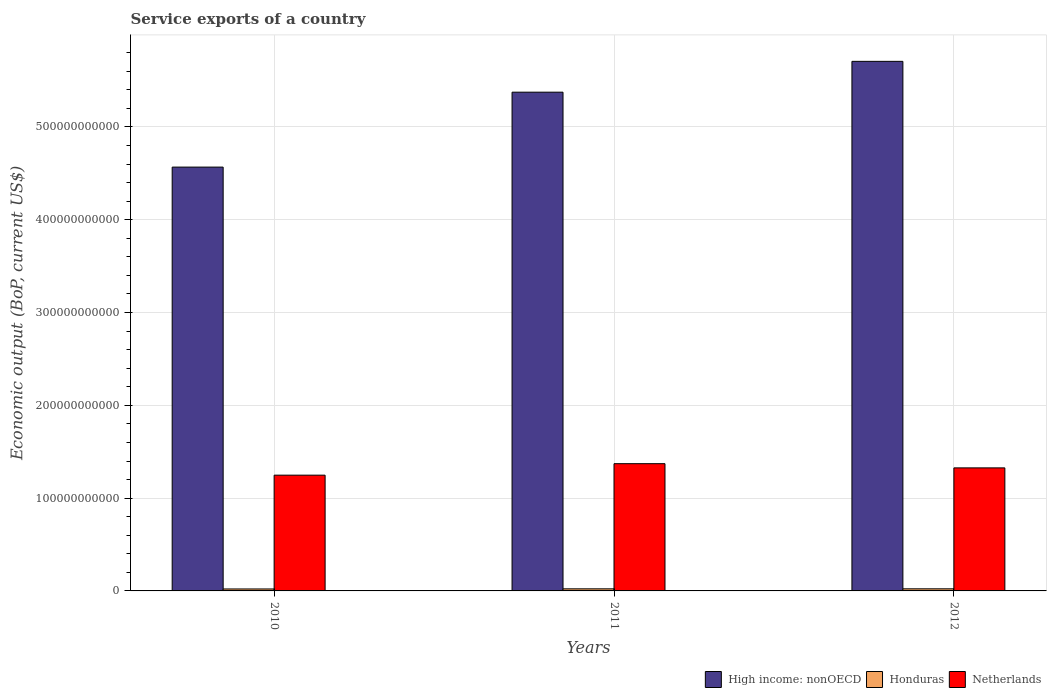Are the number of bars per tick equal to the number of legend labels?
Your answer should be compact. Yes. Are the number of bars on each tick of the X-axis equal?
Ensure brevity in your answer.  Yes. What is the label of the 3rd group of bars from the left?
Your answer should be compact. 2012. In how many cases, is the number of bars for a given year not equal to the number of legend labels?
Offer a very short reply. 0. What is the service exports in High income: nonOECD in 2010?
Give a very brief answer. 4.57e+11. Across all years, what is the maximum service exports in Netherlands?
Your answer should be compact. 1.37e+11. Across all years, what is the minimum service exports in Netherlands?
Your response must be concise. 1.25e+11. What is the total service exports in Honduras in the graph?
Offer a very short reply. 6.62e+09. What is the difference between the service exports in Honduras in 2010 and that in 2011?
Ensure brevity in your answer.  -1.46e+08. What is the difference between the service exports in High income: nonOECD in 2011 and the service exports in Netherlands in 2012?
Your response must be concise. 4.05e+11. What is the average service exports in Netherlands per year?
Give a very brief answer. 1.31e+11. In the year 2011, what is the difference between the service exports in Netherlands and service exports in High income: nonOECD?
Give a very brief answer. -4.00e+11. What is the ratio of the service exports in High income: nonOECD in 2011 to that in 2012?
Offer a terse response. 0.94. What is the difference between the highest and the second highest service exports in Honduras?
Offer a very short reply. 3.58e+06. What is the difference between the highest and the lowest service exports in Honduras?
Provide a short and direct response. 1.50e+08. In how many years, is the service exports in Netherlands greater than the average service exports in Netherlands taken over all years?
Your answer should be compact. 2. Is the sum of the service exports in High income: nonOECD in 2010 and 2011 greater than the maximum service exports in Honduras across all years?
Ensure brevity in your answer.  Yes. What does the 2nd bar from the left in 2011 represents?
Your response must be concise. Honduras. What does the 3rd bar from the right in 2010 represents?
Your answer should be compact. High income: nonOECD. Are all the bars in the graph horizontal?
Ensure brevity in your answer.  No. How many years are there in the graph?
Give a very brief answer. 3. What is the difference between two consecutive major ticks on the Y-axis?
Make the answer very short. 1.00e+11. Does the graph contain grids?
Provide a succinct answer. Yes. What is the title of the graph?
Provide a short and direct response. Service exports of a country. Does "Uruguay" appear as one of the legend labels in the graph?
Your answer should be very brief. No. What is the label or title of the X-axis?
Your answer should be compact. Years. What is the label or title of the Y-axis?
Ensure brevity in your answer.  Economic output (BoP, current US$). What is the Economic output (BoP, current US$) in High income: nonOECD in 2010?
Your answer should be compact. 4.57e+11. What is the Economic output (BoP, current US$) in Honduras in 2010?
Your answer should be compact. 2.11e+09. What is the Economic output (BoP, current US$) in Netherlands in 2010?
Provide a succinct answer. 1.25e+11. What is the Economic output (BoP, current US$) in High income: nonOECD in 2011?
Offer a very short reply. 5.37e+11. What is the Economic output (BoP, current US$) in Honduras in 2011?
Your answer should be very brief. 2.25e+09. What is the Economic output (BoP, current US$) in Netherlands in 2011?
Provide a short and direct response. 1.37e+11. What is the Economic output (BoP, current US$) in High income: nonOECD in 2012?
Keep it short and to the point. 5.71e+11. What is the Economic output (BoP, current US$) in Honduras in 2012?
Provide a short and direct response. 2.26e+09. What is the Economic output (BoP, current US$) in Netherlands in 2012?
Ensure brevity in your answer.  1.33e+11. Across all years, what is the maximum Economic output (BoP, current US$) of High income: nonOECD?
Offer a terse response. 5.71e+11. Across all years, what is the maximum Economic output (BoP, current US$) of Honduras?
Ensure brevity in your answer.  2.26e+09. Across all years, what is the maximum Economic output (BoP, current US$) of Netherlands?
Provide a succinct answer. 1.37e+11. Across all years, what is the minimum Economic output (BoP, current US$) of High income: nonOECD?
Provide a short and direct response. 4.57e+11. Across all years, what is the minimum Economic output (BoP, current US$) of Honduras?
Offer a terse response. 2.11e+09. Across all years, what is the minimum Economic output (BoP, current US$) in Netherlands?
Ensure brevity in your answer.  1.25e+11. What is the total Economic output (BoP, current US$) in High income: nonOECD in the graph?
Offer a very short reply. 1.56e+12. What is the total Economic output (BoP, current US$) of Honduras in the graph?
Your response must be concise. 6.62e+09. What is the total Economic output (BoP, current US$) in Netherlands in the graph?
Your response must be concise. 3.94e+11. What is the difference between the Economic output (BoP, current US$) in High income: nonOECD in 2010 and that in 2011?
Your response must be concise. -8.07e+1. What is the difference between the Economic output (BoP, current US$) of Honduras in 2010 and that in 2011?
Offer a very short reply. -1.46e+08. What is the difference between the Economic output (BoP, current US$) in Netherlands in 2010 and that in 2011?
Provide a succinct answer. -1.24e+1. What is the difference between the Economic output (BoP, current US$) of High income: nonOECD in 2010 and that in 2012?
Offer a very short reply. -1.14e+11. What is the difference between the Economic output (BoP, current US$) in Honduras in 2010 and that in 2012?
Keep it short and to the point. -1.50e+08. What is the difference between the Economic output (BoP, current US$) of Netherlands in 2010 and that in 2012?
Keep it short and to the point. -7.86e+09. What is the difference between the Economic output (BoP, current US$) of High income: nonOECD in 2011 and that in 2012?
Your response must be concise. -3.32e+1. What is the difference between the Economic output (BoP, current US$) in Honduras in 2011 and that in 2012?
Your response must be concise. -3.58e+06. What is the difference between the Economic output (BoP, current US$) of Netherlands in 2011 and that in 2012?
Provide a succinct answer. 4.52e+09. What is the difference between the Economic output (BoP, current US$) in High income: nonOECD in 2010 and the Economic output (BoP, current US$) in Honduras in 2011?
Keep it short and to the point. 4.54e+11. What is the difference between the Economic output (BoP, current US$) of High income: nonOECD in 2010 and the Economic output (BoP, current US$) of Netherlands in 2011?
Your answer should be compact. 3.20e+11. What is the difference between the Economic output (BoP, current US$) in Honduras in 2010 and the Economic output (BoP, current US$) in Netherlands in 2011?
Provide a succinct answer. -1.35e+11. What is the difference between the Economic output (BoP, current US$) in High income: nonOECD in 2010 and the Economic output (BoP, current US$) in Honduras in 2012?
Your response must be concise. 4.54e+11. What is the difference between the Economic output (BoP, current US$) in High income: nonOECD in 2010 and the Economic output (BoP, current US$) in Netherlands in 2012?
Your response must be concise. 3.24e+11. What is the difference between the Economic output (BoP, current US$) of Honduras in 2010 and the Economic output (BoP, current US$) of Netherlands in 2012?
Offer a terse response. -1.30e+11. What is the difference between the Economic output (BoP, current US$) of High income: nonOECD in 2011 and the Economic output (BoP, current US$) of Honduras in 2012?
Your answer should be compact. 5.35e+11. What is the difference between the Economic output (BoP, current US$) in High income: nonOECD in 2011 and the Economic output (BoP, current US$) in Netherlands in 2012?
Your response must be concise. 4.05e+11. What is the difference between the Economic output (BoP, current US$) in Honduras in 2011 and the Economic output (BoP, current US$) in Netherlands in 2012?
Offer a very short reply. -1.30e+11. What is the average Economic output (BoP, current US$) of High income: nonOECD per year?
Ensure brevity in your answer.  5.22e+11. What is the average Economic output (BoP, current US$) in Honduras per year?
Provide a short and direct response. 2.21e+09. What is the average Economic output (BoP, current US$) of Netherlands per year?
Provide a succinct answer. 1.31e+11. In the year 2010, what is the difference between the Economic output (BoP, current US$) of High income: nonOECD and Economic output (BoP, current US$) of Honduras?
Offer a terse response. 4.55e+11. In the year 2010, what is the difference between the Economic output (BoP, current US$) in High income: nonOECD and Economic output (BoP, current US$) in Netherlands?
Provide a succinct answer. 3.32e+11. In the year 2010, what is the difference between the Economic output (BoP, current US$) in Honduras and Economic output (BoP, current US$) in Netherlands?
Offer a very short reply. -1.23e+11. In the year 2011, what is the difference between the Economic output (BoP, current US$) in High income: nonOECD and Economic output (BoP, current US$) in Honduras?
Offer a very short reply. 5.35e+11. In the year 2011, what is the difference between the Economic output (BoP, current US$) of High income: nonOECD and Economic output (BoP, current US$) of Netherlands?
Provide a succinct answer. 4.00e+11. In the year 2011, what is the difference between the Economic output (BoP, current US$) in Honduras and Economic output (BoP, current US$) in Netherlands?
Ensure brevity in your answer.  -1.35e+11. In the year 2012, what is the difference between the Economic output (BoP, current US$) of High income: nonOECD and Economic output (BoP, current US$) of Honduras?
Offer a very short reply. 5.68e+11. In the year 2012, what is the difference between the Economic output (BoP, current US$) in High income: nonOECD and Economic output (BoP, current US$) in Netherlands?
Offer a very short reply. 4.38e+11. In the year 2012, what is the difference between the Economic output (BoP, current US$) in Honduras and Economic output (BoP, current US$) in Netherlands?
Provide a succinct answer. -1.30e+11. What is the ratio of the Economic output (BoP, current US$) of High income: nonOECD in 2010 to that in 2011?
Provide a short and direct response. 0.85. What is the ratio of the Economic output (BoP, current US$) in Honduras in 2010 to that in 2011?
Provide a short and direct response. 0.94. What is the ratio of the Economic output (BoP, current US$) of Netherlands in 2010 to that in 2011?
Offer a very short reply. 0.91. What is the ratio of the Economic output (BoP, current US$) in High income: nonOECD in 2010 to that in 2012?
Keep it short and to the point. 0.8. What is the ratio of the Economic output (BoP, current US$) in Honduras in 2010 to that in 2012?
Make the answer very short. 0.93. What is the ratio of the Economic output (BoP, current US$) of Netherlands in 2010 to that in 2012?
Make the answer very short. 0.94. What is the ratio of the Economic output (BoP, current US$) in High income: nonOECD in 2011 to that in 2012?
Keep it short and to the point. 0.94. What is the ratio of the Economic output (BoP, current US$) of Netherlands in 2011 to that in 2012?
Your answer should be very brief. 1.03. What is the difference between the highest and the second highest Economic output (BoP, current US$) of High income: nonOECD?
Provide a succinct answer. 3.32e+1. What is the difference between the highest and the second highest Economic output (BoP, current US$) of Honduras?
Offer a terse response. 3.58e+06. What is the difference between the highest and the second highest Economic output (BoP, current US$) in Netherlands?
Ensure brevity in your answer.  4.52e+09. What is the difference between the highest and the lowest Economic output (BoP, current US$) of High income: nonOECD?
Give a very brief answer. 1.14e+11. What is the difference between the highest and the lowest Economic output (BoP, current US$) of Honduras?
Ensure brevity in your answer.  1.50e+08. What is the difference between the highest and the lowest Economic output (BoP, current US$) in Netherlands?
Your response must be concise. 1.24e+1. 